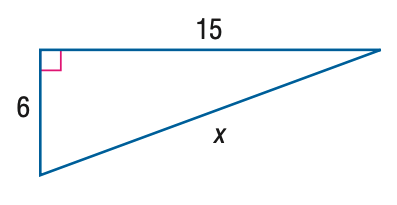Answer the mathemtical geometry problem and directly provide the correct option letter.
Question: Find x.
Choices: A: 3 \sqrt { 21 } B: 3 \sqrt { 29 } C: 17 D: 21 B 